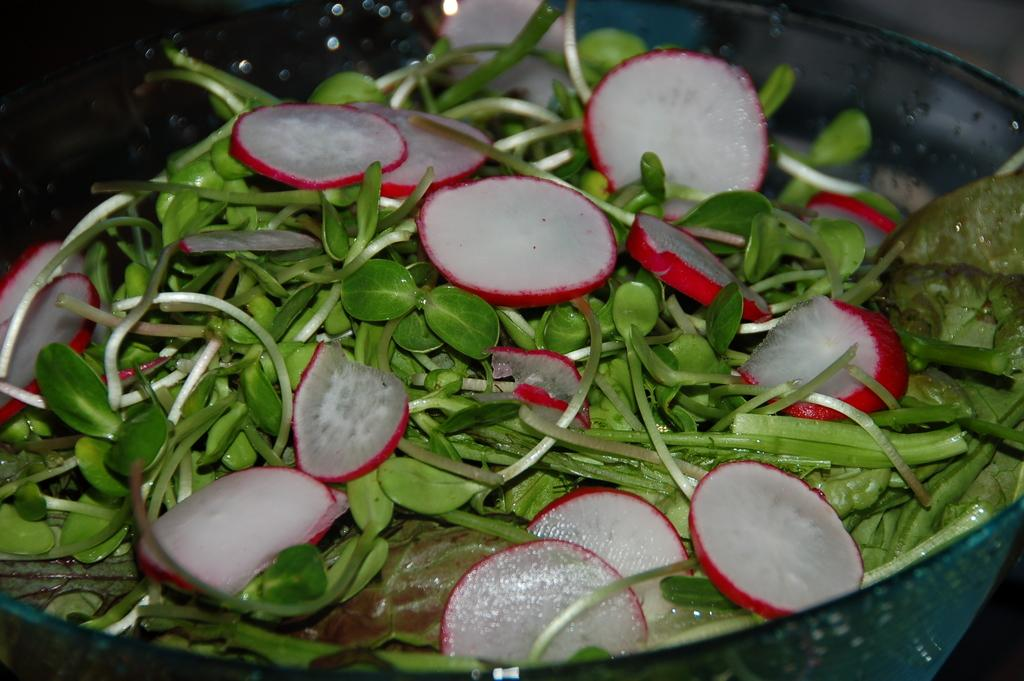What type of food can be seen in the image? There are slices of radish in the image. What other type of food is present in the image? There is leafy vegetable in the image. How are the slices and vegetable arranged in the image? The slices and vegetable are in a bowl. What can be observed about the background of the image? The background of the image is dark. Can you see a squirrel shaking a loaf of bread in the image? No, there is no squirrel or loaf of bread present in the image. 